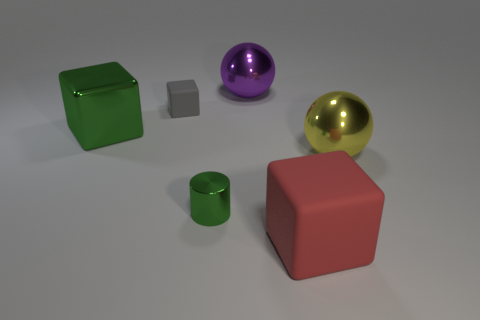There is a purple ball that is made of the same material as the small green object; what size is it?
Your response must be concise. Large. Are there any big red rubber things of the same shape as the gray matte object?
Offer a terse response. Yes. How many things are big objects to the left of the small gray thing or big cyan objects?
Your answer should be very brief. 1. What size is the metallic cylinder that is the same color as the shiny block?
Give a very brief answer. Small. There is a large metallic object that is on the left side of the small gray rubber object; is its color the same as the small thing that is in front of the big metallic cube?
Give a very brief answer. Yes. The metal cylinder is what size?
Provide a succinct answer. Small. What number of tiny things are either cyan metal cylinders or shiny spheres?
Your answer should be compact. 0. The other sphere that is the same size as the purple metal ball is what color?
Provide a short and direct response. Yellow. How many other things are the same shape as the gray matte object?
Provide a short and direct response. 2. Is there a large object made of the same material as the cylinder?
Your answer should be compact. Yes. 